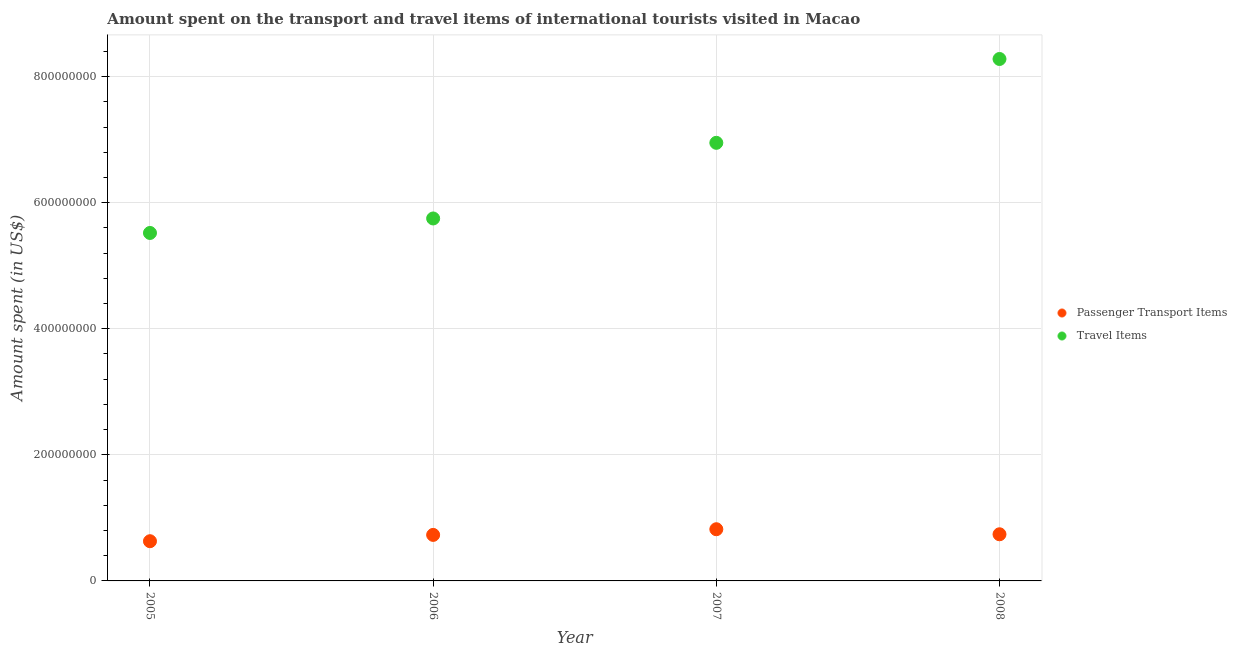How many different coloured dotlines are there?
Offer a terse response. 2. Is the number of dotlines equal to the number of legend labels?
Provide a succinct answer. Yes. What is the amount spent on passenger transport items in 2008?
Ensure brevity in your answer.  7.40e+07. Across all years, what is the maximum amount spent in travel items?
Offer a very short reply. 8.28e+08. Across all years, what is the minimum amount spent on passenger transport items?
Provide a short and direct response. 6.30e+07. What is the total amount spent on passenger transport items in the graph?
Ensure brevity in your answer.  2.92e+08. What is the difference between the amount spent in travel items in 2006 and that in 2007?
Ensure brevity in your answer.  -1.20e+08. What is the difference between the amount spent on passenger transport items in 2007 and the amount spent in travel items in 2005?
Offer a very short reply. -4.70e+08. What is the average amount spent on passenger transport items per year?
Give a very brief answer. 7.30e+07. In the year 2007, what is the difference between the amount spent in travel items and amount spent on passenger transport items?
Give a very brief answer. 6.13e+08. In how many years, is the amount spent in travel items greater than 720000000 US$?
Offer a terse response. 1. What is the ratio of the amount spent on passenger transport items in 2006 to that in 2007?
Make the answer very short. 0.89. What is the difference between the highest and the lowest amount spent in travel items?
Your answer should be compact. 2.76e+08. In how many years, is the amount spent in travel items greater than the average amount spent in travel items taken over all years?
Keep it short and to the point. 2. Is the sum of the amount spent in travel items in 2006 and 2008 greater than the maximum amount spent on passenger transport items across all years?
Your response must be concise. Yes. Does the amount spent in travel items monotonically increase over the years?
Your response must be concise. Yes. Is the amount spent in travel items strictly less than the amount spent on passenger transport items over the years?
Offer a very short reply. No. How many years are there in the graph?
Give a very brief answer. 4. What is the difference between two consecutive major ticks on the Y-axis?
Provide a succinct answer. 2.00e+08. Does the graph contain grids?
Your answer should be very brief. Yes. How many legend labels are there?
Provide a succinct answer. 2. What is the title of the graph?
Your answer should be very brief. Amount spent on the transport and travel items of international tourists visited in Macao. Does "Chemicals" appear as one of the legend labels in the graph?
Your answer should be very brief. No. What is the label or title of the X-axis?
Give a very brief answer. Year. What is the label or title of the Y-axis?
Make the answer very short. Amount spent (in US$). What is the Amount spent (in US$) of Passenger Transport Items in 2005?
Keep it short and to the point. 6.30e+07. What is the Amount spent (in US$) of Travel Items in 2005?
Offer a very short reply. 5.52e+08. What is the Amount spent (in US$) in Passenger Transport Items in 2006?
Ensure brevity in your answer.  7.30e+07. What is the Amount spent (in US$) of Travel Items in 2006?
Offer a terse response. 5.75e+08. What is the Amount spent (in US$) of Passenger Transport Items in 2007?
Provide a short and direct response. 8.20e+07. What is the Amount spent (in US$) of Travel Items in 2007?
Keep it short and to the point. 6.95e+08. What is the Amount spent (in US$) of Passenger Transport Items in 2008?
Make the answer very short. 7.40e+07. What is the Amount spent (in US$) of Travel Items in 2008?
Your response must be concise. 8.28e+08. Across all years, what is the maximum Amount spent (in US$) in Passenger Transport Items?
Ensure brevity in your answer.  8.20e+07. Across all years, what is the maximum Amount spent (in US$) of Travel Items?
Keep it short and to the point. 8.28e+08. Across all years, what is the minimum Amount spent (in US$) of Passenger Transport Items?
Provide a succinct answer. 6.30e+07. Across all years, what is the minimum Amount spent (in US$) in Travel Items?
Offer a terse response. 5.52e+08. What is the total Amount spent (in US$) in Passenger Transport Items in the graph?
Ensure brevity in your answer.  2.92e+08. What is the total Amount spent (in US$) of Travel Items in the graph?
Give a very brief answer. 2.65e+09. What is the difference between the Amount spent (in US$) of Passenger Transport Items in 2005 and that in 2006?
Your answer should be very brief. -1.00e+07. What is the difference between the Amount spent (in US$) of Travel Items in 2005 and that in 2006?
Give a very brief answer. -2.30e+07. What is the difference between the Amount spent (in US$) in Passenger Transport Items in 2005 and that in 2007?
Make the answer very short. -1.90e+07. What is the difference between the Amount spent (in US$) of Travel Items in 2005 and that in 2007?
Ensure brevity in your answer.  -1.43e+08. What is the difference between the Amount spent (in US$) in Passenger Transport Items in 2005 and that in 2008?
Your answer should be compact. -1.10e+07. What is the difference between the Amount spent (in US$) in Travel Items in 2005 and that in 2008?
Your answer should be very brief. -2.76e+08. What is the difference between the Amount spent (in US$) in Passenger Transport Items in 2006 and that in 2007?
Offer a terse response. -9.00e+06. What is the difference between the Amount spent (in US$) of Travel Items in 2006 and that in 2007?
Provide a succinct answer. -1.20e+08. What is the difference between the Amount spent (in US$) of Passenger Transport Items in 2006 and that in 2008?
Provide a short and direct response. -1.00e+06. What is the difference between the Amount spent (in US$) in Travel Items in 2006 and that in 2008?
Your response must be concise. -2.53e+08. What is the difference between the Amount spent (in US$) of Passenger Transport Items in 2007 and that in 2008?
Offer a very short reply. 8.00e+06. What is the difference between the Amount spent (in US$) of Travel Items in 2007 and that in 2008?
Your answer should be very brief. -1.33e+08. What is the difference between the Amount spent (in US$) of Passenger Transport Items in 2005 and the Amount spent (in US$) of Travel Items in 2006?
Keep it short and to the point. -5.12e+08. What is the difference between the Amount spent (in US$) of Passenger Transport Items in 2005 and the Amount spent (in US$) of Travel Items in 2007?
Make the answer very short. -6.32e+08. What is the difference between the Amount spent (in US$) in Passenger Transport Items in 2005 and the Amount spent (in US$) in Travel Items in 2008?
Ensure brevity in your answer.  -7.65e+08. What is the difference between the Amount spent (in US$) in Passenger Transport Items in 2006 and the Amount spent (in US$) in Travel Items in 2007?
Your answer should be very brief. -6.22e+08. What is the difference between the Amount spent (in US$) in Passenger Transport Items in 2006 and the Amount spent (in US$) in Travel Items in 2008?
Offer a terse response. -7.55e+08. What is the difference between the Amount spent (in US$) of Passenger Transport Items in 2007 and the Amount spent (in US$) of Travel Items in 2008?
Make the answer very short. -7.46e+08. What is the average Amount spent (in US$) in Passenger Transport Items per year?
Ensure brevity in your answer.  7.30e+07. What is the average Amount spent (in US$) of Travel Items per year?
Provide a short and direct response. 6.62e+08. In the year 2005, what is the difference between the Amount spent (in US$) of Passenger Transport Items and Amount spent (in US$) of Travel Items?
Offer a terse response. -4.89e+08. In the year 2006, what is the difference between the Amount spent (in US$) in Passenger Transport Items and Amount spent (in US$) in Travel Items?
Provide a short and direct response. -5.02e+08. In the year 2007, what is the difference between the Amount spent (in US$) in Passenger Transport Items and Amount spent (in US$) in Travel Items?
Give a very brief answer. -6.13e+08. In the year 2008, what is the difference between the Amount spent (in US$) in Passenger Transport Items and Amount spent (in US$) in Travel Items?
Make the answer very short. -7.54e+08. What is the ratio of the Amount spent (in US$) in Passenger Transport Items in 2005 to that in 2006?
Make the answer very short. 0.86. What is the ratio of the Amount spent (in US$) of Travel Items in 2005 to that in 2006?
Your answer should be very brief. 0.96. What is the ratio of the Amount spent (in US$) of Passenger Transport Items in 2005 to that in 2007?
Keep it short and to the point. 0.77. What is the ratio of the Amount spent (in US$) in Travel Items in 2005 to that in 2007?
Your answer should be very brief. 0.79. What is the ratio of the Amount spent (in US$) of Passenger Transport Items in 2005 to that in 2008?
Make the answer very short. 0.85. What is the ratio of the Amount spent (in US$) in Passenger Transport Items in 2006 to that in 2007?
Provide a short and direct response. 0.89. What is the ratio of the Amount spent (in US$) of Travel Items in 2006 to that in 2007?
Provide a short and direct response. 0.83. What is the ratio of the Amount spent (in US$) in Passenger Transport Items in 2006 to that in 2008?
Offer a very short reply. 0.99. What is the ratio of the Amount spent (in US$) in Travel Items in 2006 to that in 2008?
Your response must be concise. 0.69. What is the ratio of the Amount spent (in US$) of Passenger Transport Items in 2007 to that in 2008?
Offer a terse response. 1.11. What is the ratio of the Amount spent (in US$) of Travel Items in 2007 to that in 2008?
Your response must be concise. 0.84. What is the difference between the highest and the second highest Amount spent (in US$) of Travel Items?
Offer a very short reply. 1.33e+08. What is the difference between the highest and the lowest Amount spent (in US$) in Passenger Transport Items?
Provide a short and direct response. 1.90e+07. What is the difference between the highest and the lowest Amount spent (in US$) in Travel Items?
Make the answer very short. 2.76e+08. 